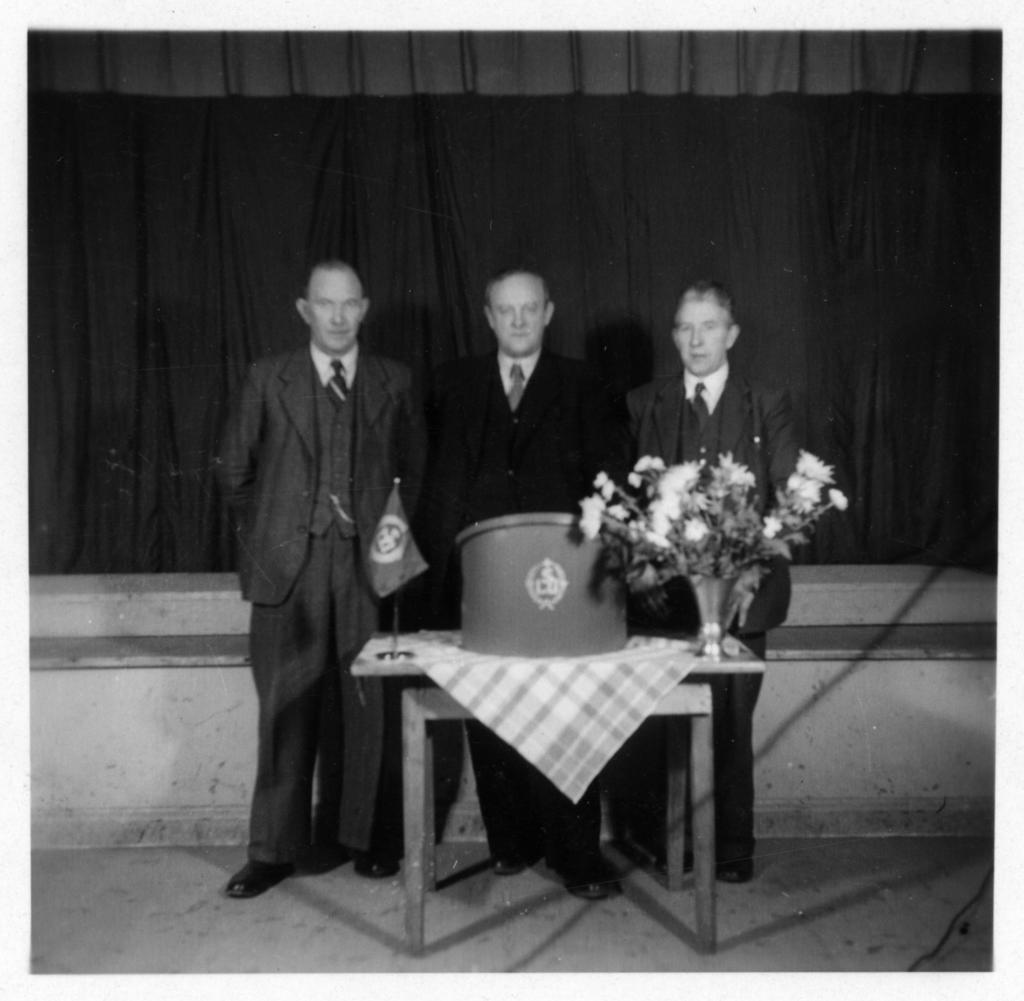What is the color scheme of the image? The image is black and white. How many people are in the image? There are three persons standing in the image. What is in front of the persons? There is a table in front of the persons. What is on the table? There is a cloth, a flag, and flowers on the table. Is there a water fountain in the image? There is no water fountain present in the image. What type of quince is being served on the table? There is no quince present in the image; only a flag and flowers are on the table. 